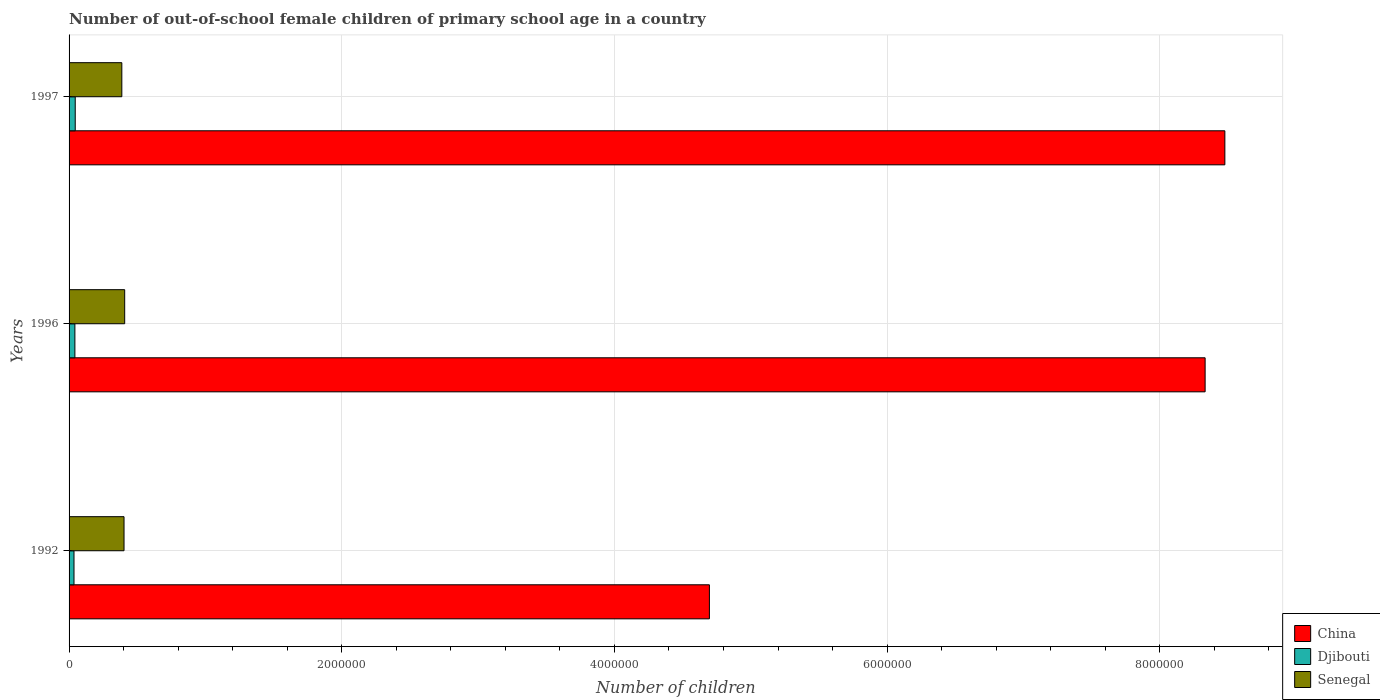How many groups of bars are there?
Your answer should be compact. 3. How many bars are there on the 3rd tick from the top?
Your response must be concise. 3. What is the number of out-of-school female children in Djibouti in 1992?
Make the answer very short. 3.61e+04. Across all years, what is the maximum number of out-of-school female children in Senegal?
Offer a very short reply. 4.08e+05. Across all years, what is the minimum number of out-of-school female children in China?
Offer a terse response. 4.70e+06. In which year was the number of out-of-school female children in Djibouti maximum?
Your answer should be compact. 1997. In which year was the number of out-of-school female children in China minimum?
Offer a terse response. 1992. What is the total number of out-of-school female children in Djibouti in the graph?
Offer a very short reply. 1.24e+05. What is the difference between the number of out-of-school female children in China in 1992 and that in 1996?
Offer a very short reply. -3.64e+06. What is the difference between the number of out-of-school female children in China in 1996 and the number of out-of-school female children in Djibouti in 1997?
Give a very brief answer. 8.29e+06. What is the average number of out-of-school female children in Senegal per year?
Offer a very short reply. 3.99e+05. In the year 1992, what is the difference between the number of out-of-school female children in Djibouti and number of out-of-school female children in Senegal?
Make the answer very short. -3.67e+05. In how many years, is the number of out-of-school female children in Senegal greater than 4800000 ?
Make the answer very short. 0. What is the ratio of the number of out-of-school female children in Senegal in 1992 to that in 1996?
Keep it short and to the point. 0.99. Is the number of out-of-school female children in Senegal in 1992 less than that in 1997?
Your response must be concise. No. Is the difference between the number of out-of-school female children in Djibouti in 1996 and 1997 greater than the difference between the number of out-of-school female children in Senegal in 1996 and 1997?
Your response must be concise. No. What is the difference between the highest and the second highest number of out-of-school female children in Djibouti?
Provide a succinct answer. 2505. What is the difference between the highest and the lowest number of out-of-school female children in Djibouti?
Your response must be concise. 9110. Is the sum of the number of out-of-school female children in Senegal in 1992 and 1996 greater than the maximum number of out-of-school female children in Djibouti across all years?
Provide a short and direct response. Yes. What does the 1st bar from the top in 1996 represents?
Your answer should be compact. Senegal. What does the 3rd bar from the bottom in 1992 represents?
Keep it short and to the point. Senegal. How many bars are there?
Provide a short and direct response. 9. What is the difference between two consecutive major ticks on the X-axis?
Provide a short and direct response. 2.00e+06. Are the values on the major ticks of X-axis written in scientific E-notation?
Make the answer very short. No. Does the graph contain grids?
Provide a succinct answer. Yes. How many legend labels are there?
Offer a very short reply. 3. How are the legend labels stacked?
Offer a very short reply. Vertical. What is the title of the graph?
Provide a short and direct response. Number of out-of-school female children of primary school age in a country. Does "Latin America(developing only)" appear as one of the legend labels in the graph?
Make the answer very short. No. What is the label or title of the X-axis?
Offer a terse response. Number of children. What is the label or title of the Y-axis?
Your answer should be compact. Years. What is the Number of children of China in 1992?
Keep it short and to the point. 4.70e+06. What is the Number of children in Djibouti in 1992?
Give a very brief answer. 3.61e+04. What is the Number of children in Senegal in 1992?
Keep it short and to the point. 4.03e+05. What is the Number of children in China in 1996?
Make the answer very short. 8.33e+06. What is the Number of children in Djibouti in 1996?
Your answer should be compact. 4.27e+04. What is the Number of children of Senegal in 1996?
Keep it short and to the point. 4.08e+05. What is the Number of children in China in 1997?
Provide a short and direct response. 8.48e+06. What is the Number of children of Djibouti in 1997?
Your answer should be compact. 4.52e+04. What is the Number of children of Senegal in 1997?
Keep it short and to the point. 3.87e+05. Across all years, what is the maximum Number of children in China?
Your answer should be very brief. 8.48e+06. Across all years, what is the maximum Number of children in Djibouti?
Your answer should be very brief. 4.52e+04. Across all years, what is the maximum Number of children of Senegal?
Ensure brevity in your answer.  4.08e+05. Across all years, what is the minimum Number of children in China?
Make the answer very short. 4.70e+06. Across all years, what is the minimum Number of children of Djibouti?
Your response must be concise. 3.61e+04. Across all years, what is the minimum Number of children of Senegal?
Provide a short and direct response. 3.87e+05. What is the total Number of children in China in the graph?
Provide a succinct answer. 2.15e+07. What is the total Number of children in Djibouti in the graph?
Your answer should be compact. 1.24e+05. What is the total Number of children of Senegal in the graph?
Your answer should be very brief. 1.20e+06. What is the difference between the Number of children of China in 1992 and that in 1996?
Offer a very short reply. -3.64e+06. What is the difference between the Number of children in Djibouti in 1992 and that in 1996?
Keep it short and to the point. -6605. What is the difference between the Number of children in Senegal in 1992 and that in 1996?
Offer a terse response. -4802. What is the difference between the Number of children of China in 1992 and that in 1997?
Give a very brief answer. -3.78e+06. What is the difference between the Number of children of Djibouti in 1992 and that in 1997?
Give a very brief answer. -9110. What is the difference between the Number of children in Senegal in 1992 and that in 1997?
Offer a terse response. 1.61e+04. What is the difference between the Number of children in China in 1996 and that in 1997?
Your answer should be compact. -1.45e+05. What is the difference between the Number of children in Djibouti in 1996 and that in 1997?
Your answer should be very brief. -2505. What is the difference between the Number of children of Senegal in 1996 and that in 1997?
Make the answer very short. 2.09e+04. What is the difference between the Number of children in China in 1992 and the Number of children in Djibouti in 1996?
Offer a terse response. 4.65e+06. What is the difference between the Number of children of China in 1992 and the Number of children of Senegal in 1996?
Give a very brief answer. 4.29e+06. What is the difference between the Number of children in Djibouti in 1992 and the Number of children in Senegal in 1996?
Your response must be concise. -3.72e+05. What is the difference between the Number of children in China in 1992 and the Number of children in Djibouti in 1997?
Give a very brief answer. 4.65e+06. What is the difference between the Number of children of China in 1992 and the Number of children of Senegal in 1997?
Provide a short and direct response. 4.31e+06. What is the difference between the Number of children in Djibouti in 1992 and the Number of children in Senegal in 1997?
Make the answer very short. -3.51e+05. What is the difference between the Number of children of China in 1996 and the Number of children of Djibouti in 1997?
Offer a terse response. 8.29e+06. What is the difference between the Number of children of China in 1996 and the Number of children of Senegal in 1997?
Your answer should be compact. 7.95e+06. What is the difference between the Number of children in Djibouti in 1996 and the Number of children in Senegal in 1997?
Keep it short and to the point. -3.44e+05. What is the average Number of children of China per year?
Your response must be concise. 7.17e+06. What is the average Number of children in Djibouti per year?
Provide a short and direct response. 4.14e+04. What is the average Number of children of Senegal per year?
Offer a terse response. 3.99e+05. In the year 1992, what is the difference between the Number of children of China and Number of children of Djibouti?
Your response must be concise. 4.66e+06. In the year 1992, what is the difference between the Number of children of China and Number of children of Senegal?
Offer a terse response. 4.29e+06. In the year 1992, what is the difference between the Number of children of Djibouti and Number of children of Senegal?
Your answer should be very brief. -3.67e+05. In the year 1996, what is the difference between the Number of children of China and Number of children of Djibouti?
Give a very brief answer. 8.29e+06. In the year 1996, what is the difference between the Number of children of China and Number of children of Senegal?
Keep it short and to the point. 7.92e+06. In the year 1996, what is the difference between the Number of children of Djibouti and Number of children of Senegal?
Your answer should be compact. -3.65e+05. In the year 1997, what is the difference between the Number of children in China and Number of children in Djibouti?
Offer a very short reply. 8.43e+06. In the year 1997, what is the difference between the Number of children of China and Number of children of Senegal?
Provide a short and direct response. 8.09e+06. In the year 1997, what is the difference between the Number of children in Djibouti and Number of children in Senegal?
Your answer should be very brief. -3.42e+05. What is the ratio of the Number of children in China in 1992 to that in 1996?
Your answer should be very brief. 0.56. What is the ratio of the Number of children in Djibouti in 1992 to that in 1996?
Provide a short and direct response. 0.85. What is the ratio of the Number of children of China in 1992 to that in 1997?
Offer a terse response. 0.55. What is the ratio of the Number of children in Djibouti in 1992 to that in 1997?
Ensure brevity in your answer.  0.8. What is the ratio of the Number of children in Senegal in 1992 to that in 1997?
Make the answer very short. 1.04. What is the ratio of the Number of children in China in 1996 to that in 1997?
Your response must be concise. 0.98. What is the ratio of the Number of children of Djibouti in 1996 to that in 1997?
Offer a very short reply. 0.94. What is the ratio of the Number of children of Senegal in 1996 to that in 1997?
Your answer should be very brief. 1.05. What is the difference between the highest and the second highest Number of children of China?
Give a very brief answer. 1.45e+05. What is the difference between the highest and the second highest Number of children in Djibouti?
Provide a succinct answer. 2505. What is the difference between the highest and the second highest Number of children of Senegal?
Your answer should be very brief. 4802. What is the difference between the highest and the lowest Number of children in China?
Ensure brevity in your answer.  3.78e+06. What is the difference between the highest and the lowest Number of children of Djibouti?
Keep it short and to the point. 9110. What is the difference between the highest and the lowest Number of children of Senegal?
Make the answer very short. 2.09e+04. 